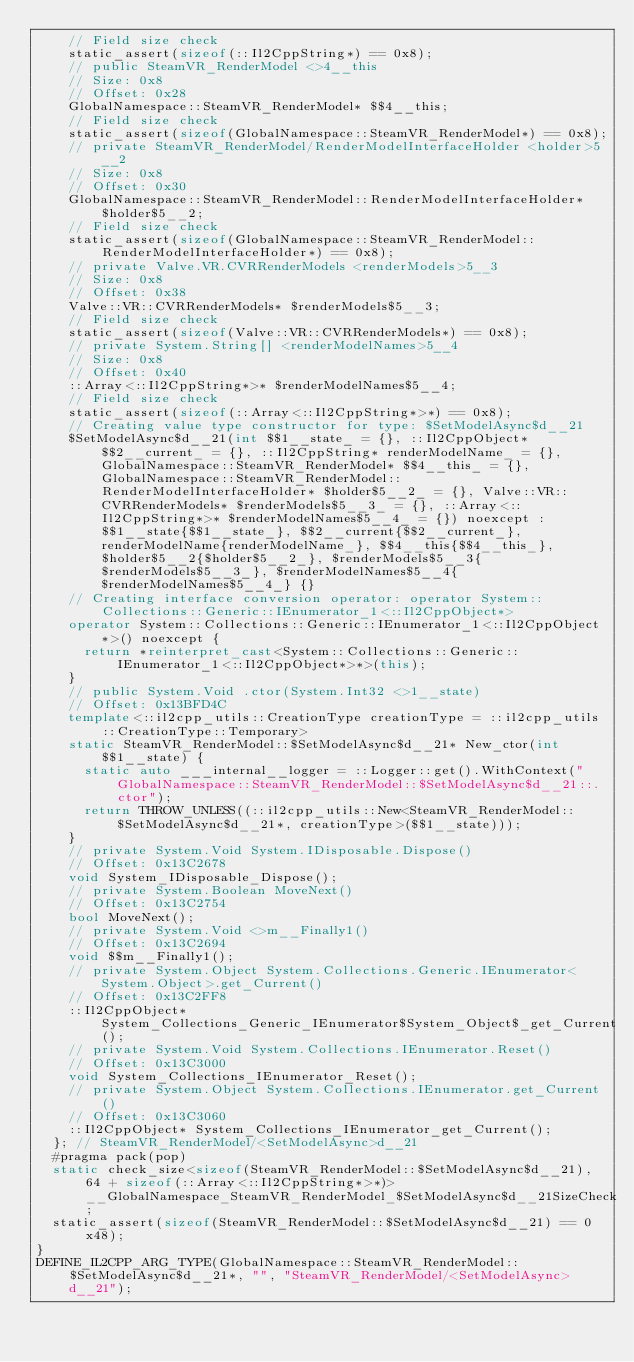<code> <loc_0><loc_0><loc_500><loc_500><_C++_>    // Field size check
    static_assert(sizeof(::Il2CppString*) == 0x8);
    // public SteamVR_RenderModel <>4__this
    // Size: 0x8
    // Offset: 0x28
    GlobalNamespace::SteamVR_RenderModel* $$4__this;
    // Field size check
    static_assert(sizeof(GlobalNamespace::SteamVR_RenderModel*) == 0x8);
    // private SteamVR_RenderModel/RenderModelInterfaceHolder <holder>5__2
    // Size: 0x8
    // Offset: 0x30
    GlobalNamespace::SteamVR_RenderModel::RenderModelInterfaceHolder* $holder$5__2;
    // Field size check
    static_assert(sizeof(GlobalNamespace::SteamVR_RenderModel::RenderModelInterfaceHolder*) == 0x8);
    // private Valve.VR.CVRRenderModels <renderModels>5__3
    // Size: 0x8
    // Offset: 0x38
    Valve::VR::CVRRenderModels* $renderModels$5__3;
    // Field size check
    static_assert(sizeof(Valve::VR::CVRRenderModels*) == 0x8);
    // private System.String[] <renderModelNames>5__4
    // Size: 0x8
    // Offset: 0x40
    ::Array<::Il2CppString*>* $renderModelNames$5__4;
    // Field size check
    static_assert(sizeof(::Array<::Il2CppString*>*) == 0x8);
    // Creating value type constructor for type: $SetModelAsync$d__21
    $SetModelAsync$d__21(int $$1__state_ = {}, ::Il2CppObject* $$2__current_ = {}, ::Il2CppString* renderModelName_ = {}, GlobalNamespace::SteamVR_RenderModel* $$4__this_ = {}, GlobalNamespace::SteamVR_RenderModel::RenderModelInterfaceHolder* $holder$5__2_ = {}, Valve::VR::CVRRenderModels* $renderModels$5__3_ = {}, ::Array<::Il2CppString*>* $renderModelNames$5__4_ = {}) noexcept : $$1__state{$$1__state_}, $$2__current{$$2__current_}, renderModelName{renderModelName_}, $$4__this{$$4__this_}, $holder$5__2{$holder$5__2_}, $renderModels$5__3{$renderModels$5__3_}, $renderModelNames$5__4{$renderModelNames$5__4_} {}
    // Creating interface conversion operator: operator System::Collections::Generic::IEnumerator_1<::Il2CppObject*>
    operator System::Collections::Generic::IEnumerator_1<::Il2CppObject*>() noexcept {
      return *reinterpret_cast<System::Collections::Generic::IEnumerator_1<::Il2CppObject*>*>(this);
    }
    // public System.Void .ctor(System.Int32 <>1__state)
    // Offset: 0x13BFD4C
    template<::il2cpp_utils::CreationType creationType = ::il2cpp_utils::CreationType::Temporary>
    static SteamVR_RenderModel::$SetModelAsync$d__21* New_ctor(int $$1__state) {
      static auto ___internal__logger = ::Logger::get().WithContext("GlobalNamespace::SteamVR_RenderModel::$SetModelAsync$d__21::.ctor");
      return THROW_UNLESS((::il2cpp_utils::New<SteamVR_RenderModel::$SetModelAsync$d__21*, creationType>($$1__state)));
    }
    // private System.Void System.IDisposable.Dispose()
    // Offset: 0x13C2678
    void System_IDisposable_Dispose();
    // private System.Boolean MoveNext()
    // Offset: 0x13C2754
    bool MoveNext();
    // private System.Void <>m__Finally1()
    // Offset: 0x13C2694
    void $$m__Finally1();
    // private System.Object System.Collections.Generic.IEnumerator<System.Object>.get_Current()
    // Offset: 0x13C2FF8
    ::Il2CppObject* System_Collections_Generic_IEnumerator$System_Object$_get_Current();
    // private System.Void System.Collections.IEnumerator.Reset()
    // Offset: 0x13C3000
    void System_Collections_IEnumerator_Reset();
    // private System.Object System.Collections.IEnumerator.get_Current()
    // Offset: 0x13C3060
    ::Il2CppObject* System_Collections_IEnumerator_get_Current();
  }; // SteamVR_RenderModel/<SetModelAsync>d__21
  #pragma pack(pop)
  static check_size<sizeof(SteamVR_RenderModel::$SetModelAsync$d__21), 64 + sizeof(::Array<::Il2CppString*>*)> __GlobalNamespace_SteamVR_RenderModel_$SetModelAsync$d__21SizeCheck;
  static_assert(sizeof(SteamVR_RenderModel::$SetModelAsync$d__21) == 0x48);
}
DEFINE_IL2CPP_ARG_TYPE(GlobalNamespace::SteamVR_RenderModel::$SetModelAsync$d__21*, "", "SteamVR_RenderModel/<SetModelAsync>d__21");
</code> 